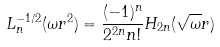Convert formula to latex. <formula><loc_0><loc_0><loc_500><loc_500>L ^ { - 1 / 2 } _ { n } ( \omega r ^ { 2 } ) = \frac { ( - 1 ) ^ { n } } { 2 ^ { 2 n } n ! } H _ { 2 n } ( \sqrt { \omega } r )</formula> 